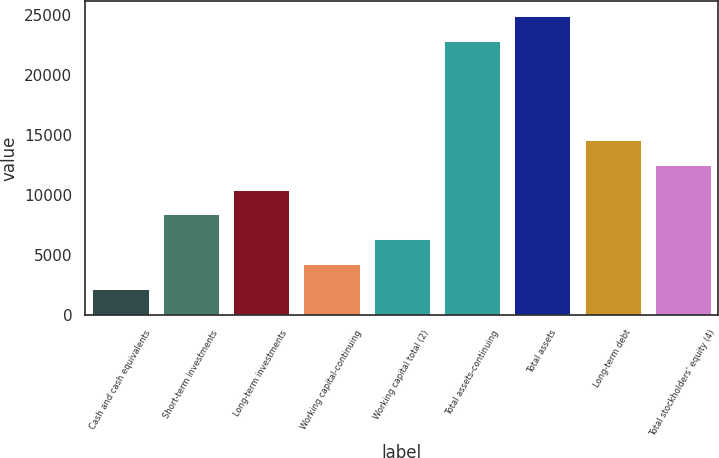Convert chart. <chart><loc_0><loc_0><loc_500><loc_500><bar_chart><fcel>Cash and cash equivalents<fcel>Short-term investments<fcel>Long-term investments<fcel>Working capital-continuing<fcel>Working capital total (2)<fcel>Total assets-continuing<fcel>Total assets<fcel>Long-term debt<fcel>Total stockholders' equity (4)<nl><fcel>2202<fcel>8387.1<fcel>10448.8<fcel>4263.7<fcel>6325.4<fcel>22819<fcel>24880.7<fcel>14572.2<fcel>12510.5<nl></chart> 